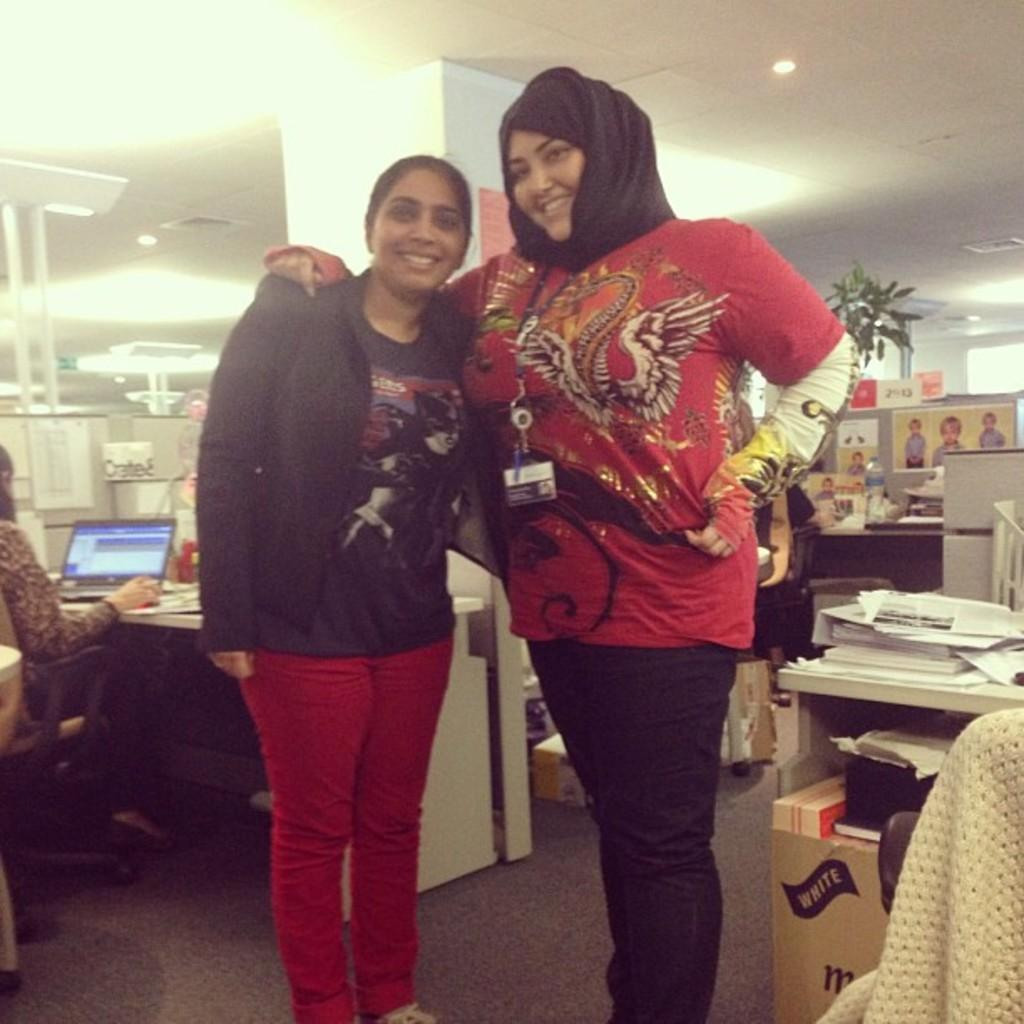How many women are in the image? There are two women in the image. Where are the women positioned in the image? The women are standing in the front. What is the person sitting on the chair doing in the image? There is a person sitting on a chair in the image, and they have a laptop in front of them. What type of tramp can be seen in the image? There is no tramp present in the image. What is the most prominent feature of the person sitting on the chair's chin? There is no chin visible in the image, as the person is facing the laptop. 